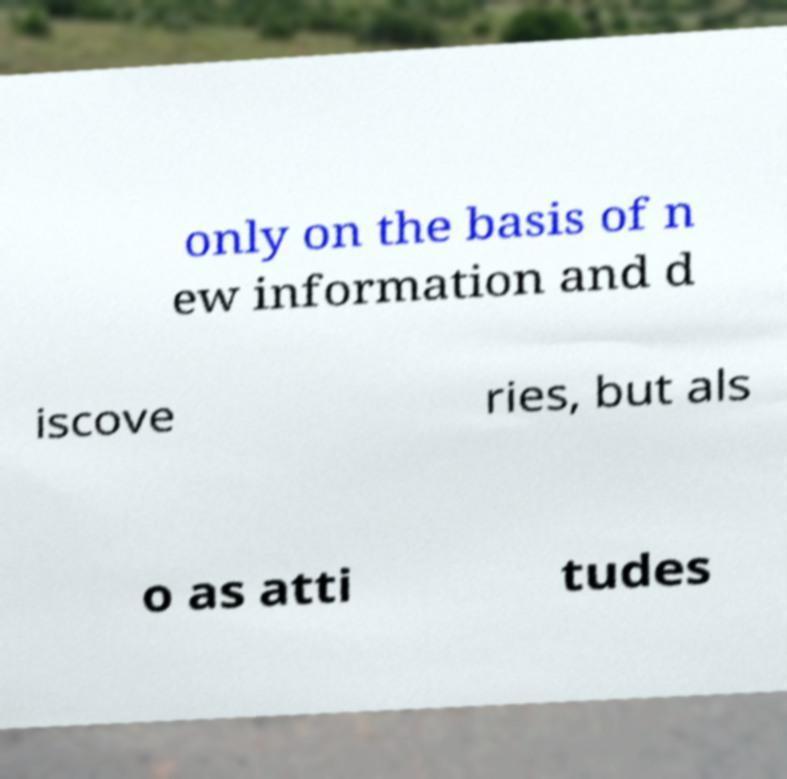I need the written content from this picture converted into text. Can you do that? only on the basis of n ew information and d iscove ries, but als o as atti tudes 